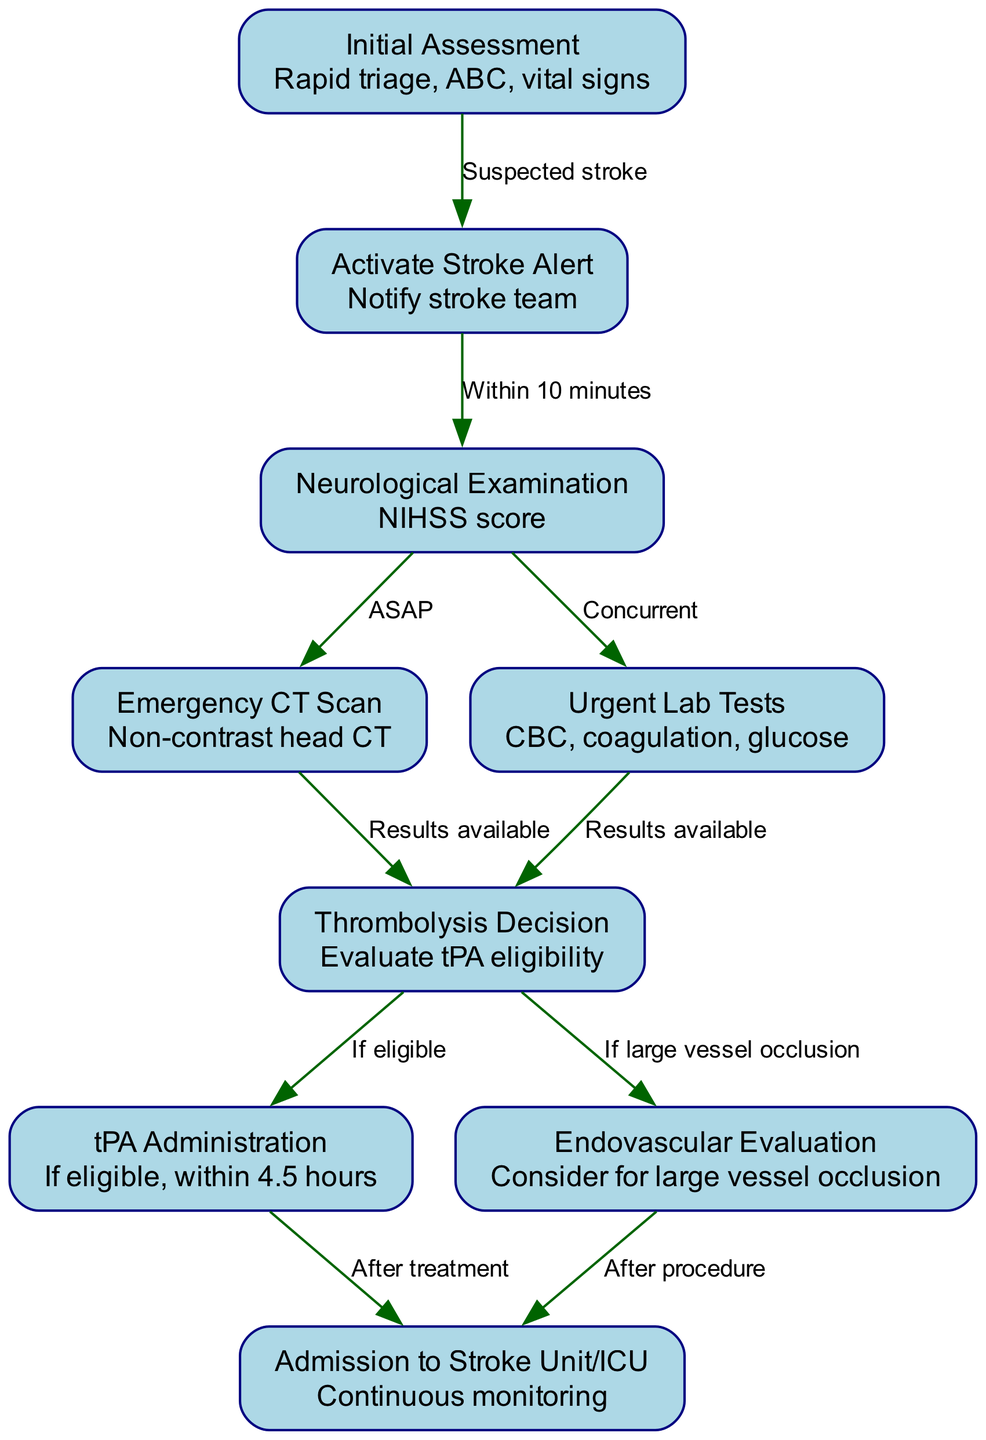What is the first step in the stroke pathway? The first node in the diagram is "Initial Assessment," which indicates that the process begins with this step.
Answer: Initial Assessment How many nodes are there in the pathway? By counting the nodes listed in the data, there are a total of 9 nodes in the diagram.
Answer: 9 What procedure follows the neurological examination? The edge connecting "neurological_exam" to "ct_scan" indicates that the next step is the "Emergency CT Scan" after the neurological examination.
Answer: Emergency CT Scan What is the time requirement to activate stroke alert after the initial assessment? The diagram specifies that the stroke alert must be activated "Within 10 minutes" after the initial assessment, indicating a time-sensitive requirement.
Answer: Within 10 minutes What tests are done concurrently with the CT scan? The diagram shows an edge from "neurological_exam" to "lab_tests," implying that urgent lab tests are performed at the same time as the CT scan for efficiency.
Answer: Urgent Lab Tests What determines eligibility for tPA administration? The decision-making process leading to tPA administration depends on the evaluation of the patient's eligibility for thrombolysis, as indicated by the edge from "thrombolysis_decision" to "tpa_administration."
Answer: Thrombolysis Decision What happens if a patient is found to have a large vessel occlusion? The pathway indicates that if a large vessel occlusion is identified, an "Endovascular Evaluation" occurs, which is crucial for further intervention.
Answer: Endovascular Evaluation What is the endpoint after tPA administration? Following the administration of tPA, the patient will be admitted to the stroke unit or ICU for continuous monitoring, as shown by the connection to "admission_icu."
Answer: Admission to Stroke Unit/ICU How are lab results factored into the thrombolysis decision? There are two connections leading into the "thrombolysis_decision" node: one from "ct_scan" and another from "lab_tests," indicating that both test results need to be available for assessing eligibility for treatment.
Answer: Lab Tests and CT Scan Results 